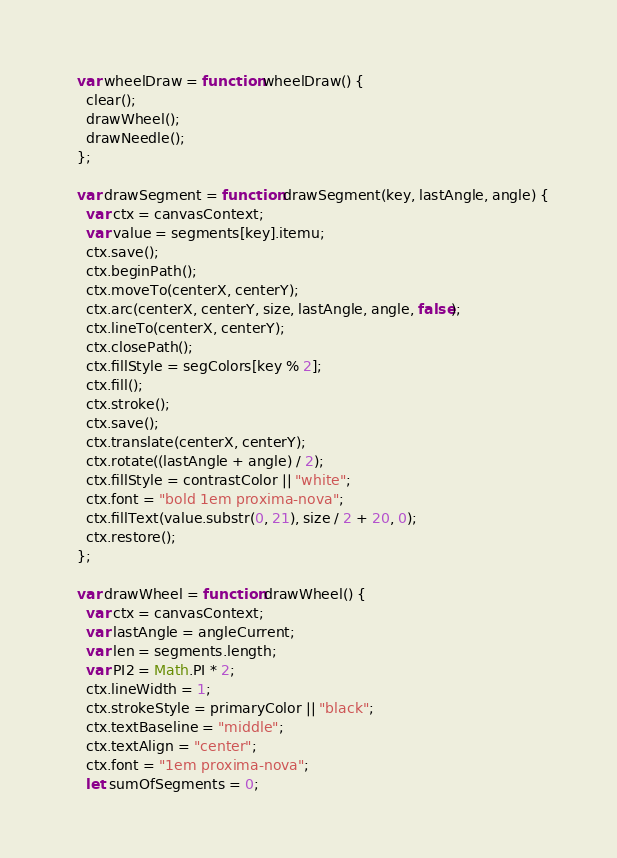<code> <loc_0><loc_0><loc_500><loc_500><_JavaScript_>  var wheelDraw = function wheelDraw() {
    clear();
    drawWheel();
    drawNeedle();
  };

  var drawSegment = function drawSegment(key, lastAngle, angle) {
    var ctx = canvasContext;
    var value = segments[key].itemu;
    ctx.save();
    ctx.beginPath();
    ctx.moveTo(centerX, centerY);
    ctx.arc(centerX, centerY, size, lastAngle, angle, false);
    ctx.lineTo(centerX, centerY);
    ctx.closePath();
    ctx.fillStyle = segColors[key % 2];
    ctx.fill();
    ctx.stroke();
    ctx.save();
    ctx.translate(centerX, centerY);
    ctx.rotate((lastAngle + angle) / 2);
    ctx.fillStyle = contrastColor || "white";
    ctx.font = "bold 1em proxima-nova";
    ctx.fillText(value.substr(0, 21), size / 2 + 20, 0);
    ctx.restore();
  };

  var drawWheel = function drawWheel() {
    var ctx = canvasContext;
    var lastAngle = angleCurrent;
    var len = segments.length;
    var PI2 = Math.PI * 2;
    ctx.lineWidth = 1;
    ctx.strokeStyle = primaryColor || "black";
    ctx.textBaseline = "middle";
    ctx.textAlign = "center";
    ctx.font = "1em proxima-nova";
    let sumOfSegments = 0;</code> 